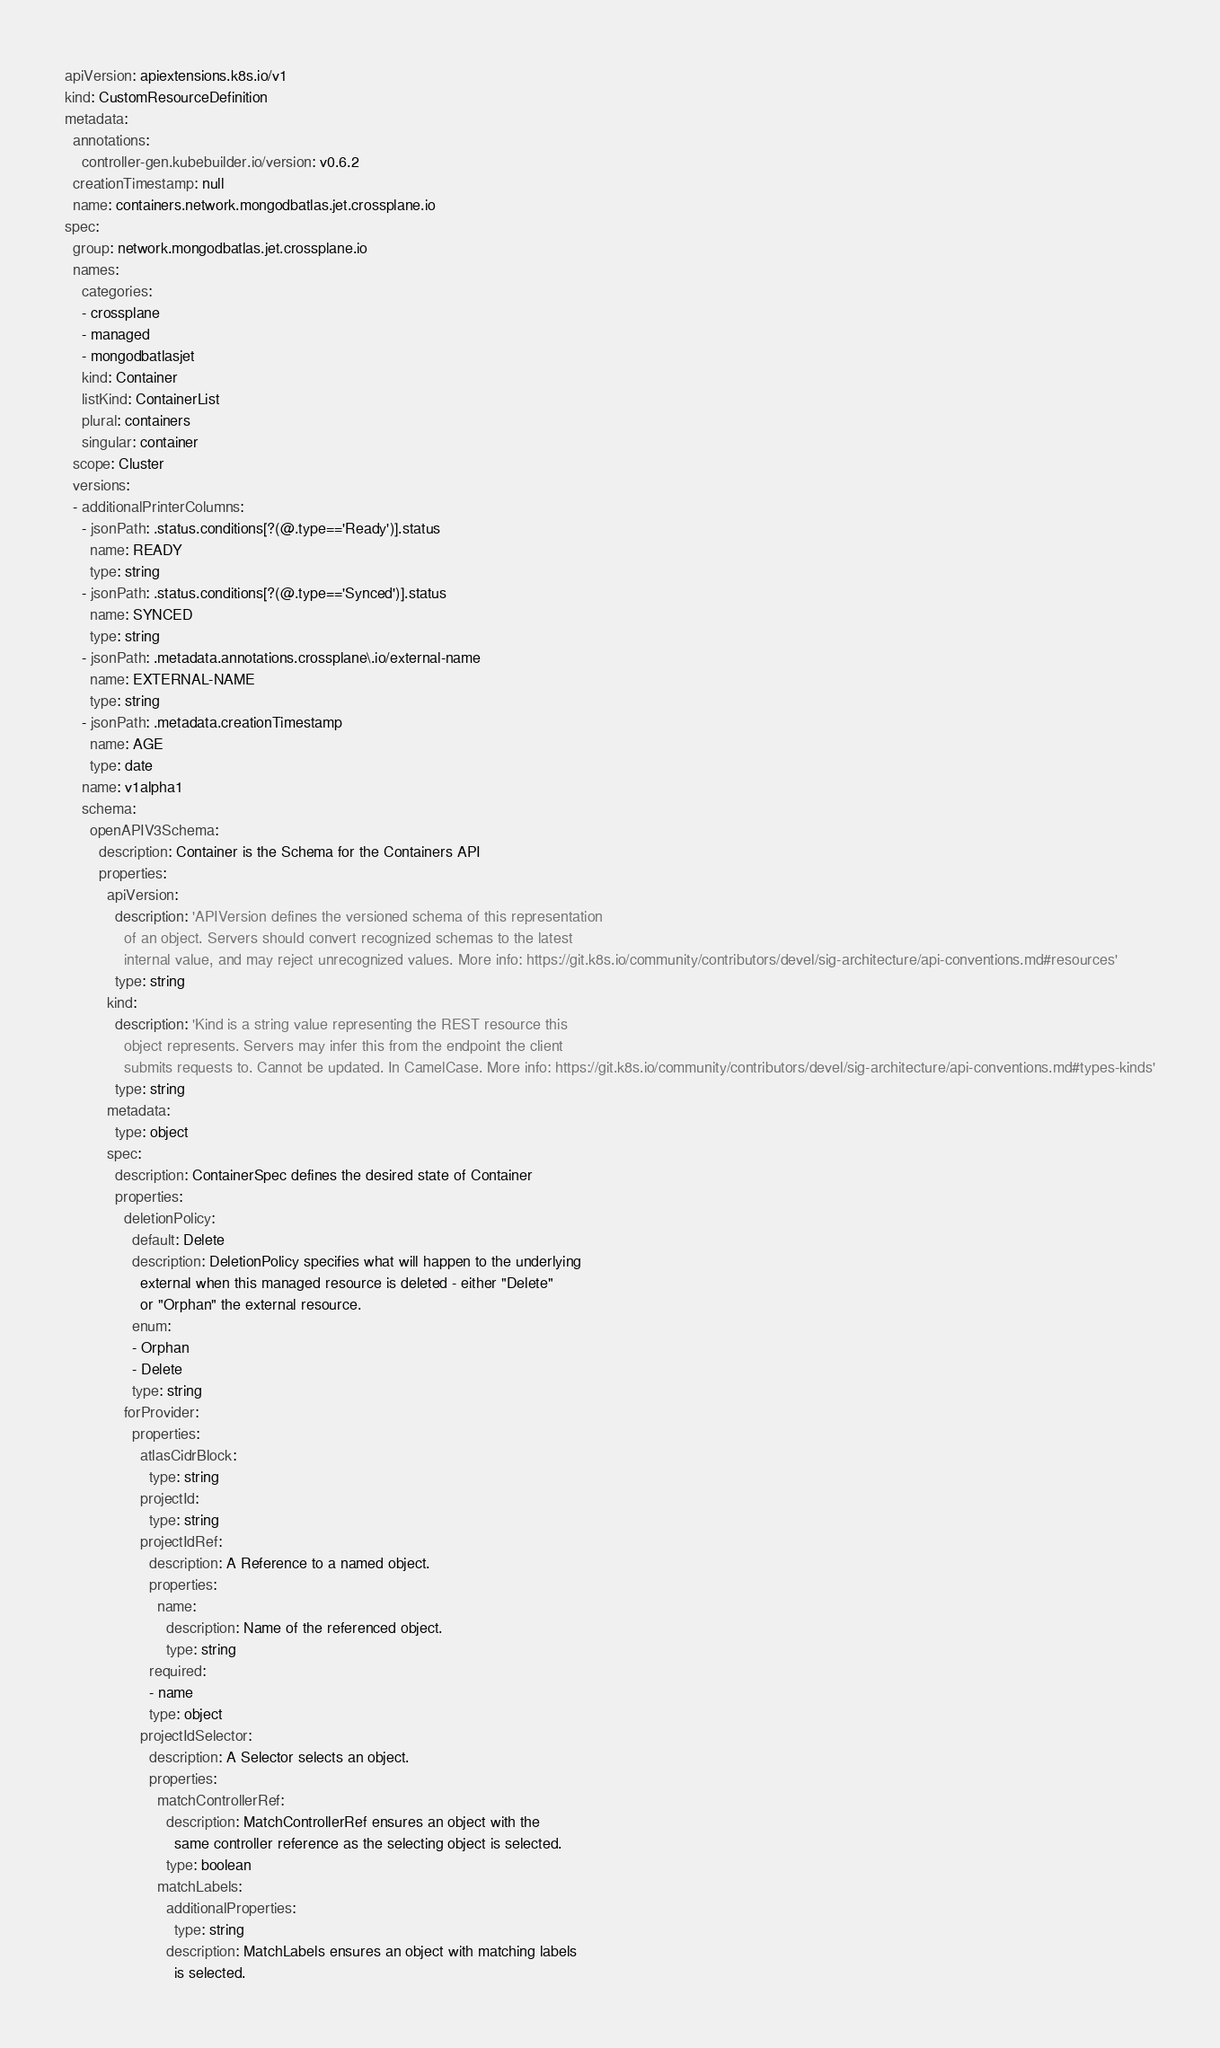Convert code to text. <code><loc_0><loc_0><loc_500><loc_500><_YAML_>apiVersion: apiextensions.k8s.io/v1
kind: CustomResourceDefinition
metadata:
  annotations:
    controller-gen.kubebuilder.io/version: v0.6.2
  creationTimestamp: null
  name: containers.network.mongodbatlas.jet.crossplane.io
spec:
  group: network.mongodbatlas.jet.crossplane.io
  names:
    categories:
    - crossplane
    - managed
    - mongodbatlasjet
    kind: Container
    listKind: ContainerList
    plural: containers
    singular: container
  scope: Cluster
  versions:
  - additionalPrinterColumns:
    - jsonPath: .status.conditions[?(@.type=='Ready')].status
      name: READY
      type: string
    - jsonPath: .status.conditions[?(@.type=='Synced')].status
      name: SYNCED
      type: string
    - jsonPath: .metadata.annotations.crossplane\.io/external-name
      name: EXTERNAL-NAME
      type: string
    - jsonPath: .metadata.creationTimestamp
      name: AGE
      type: date
    name: v1alpha1
    schema:
      openAPIV3Schema:
        description: Container is the Schema for the Containers API
        properties:
          apiVersion:
            description: 'APIVersion defines the versioned schema of this representation
              of an object. Servers should convert recognized schemas to the latest
              internal value, and may reject unrecognized values. More info: https://git.k8s.io/community/contributors/devel/sig-architecture/api-conventions.md#resources'
            type: string
          kind:
            description: 'Kind is a string value representing the REST resource this
              object represents. Servers may infer this from the endpoint the client
              submits requests to. Cannot be updated. In CamelCase. More info: https://git.k8s.io/community/contributors/devel/sig-architecture/api-conventions.md#types-kinds'
            type: string
          metadata:
            type: object
          spec:
            description: ContainerSpec defines the desired state of Container
            properties:
              deletionPolicy:
                default: Delete
                description: DeletionPolicy specifies what will happen to the underlying
                  external when this managed resource is deleted - either "Delete"
                  or "Orphan" the external resource.
                enum:
                - Orphan
                - Delete
                type: string
              forProvider:
                properties:
                  atlasCidrBlock:
                    type: string
                  projectId:
                    type: string
                  projectIdRef:
                    description: A Reference to a named object.
                    properties:
                      name:
                        description: Name of the referenced object.
                        type: string
                    required:
                    - name
                    type: object
                  projectIdSelector:
                    description: A Selector selects an object.
                    properties:
                      matchControllerRef:
                        description: MatchControllerRef ensures an object with the
                          same controller reference as the selecting object is selected.
                        type: boolean
                      matchLabels:
                        additionalProperties:
                          type: string
                        description: MatchLabels ensures an object with matching labels
                          is selected.</code> 